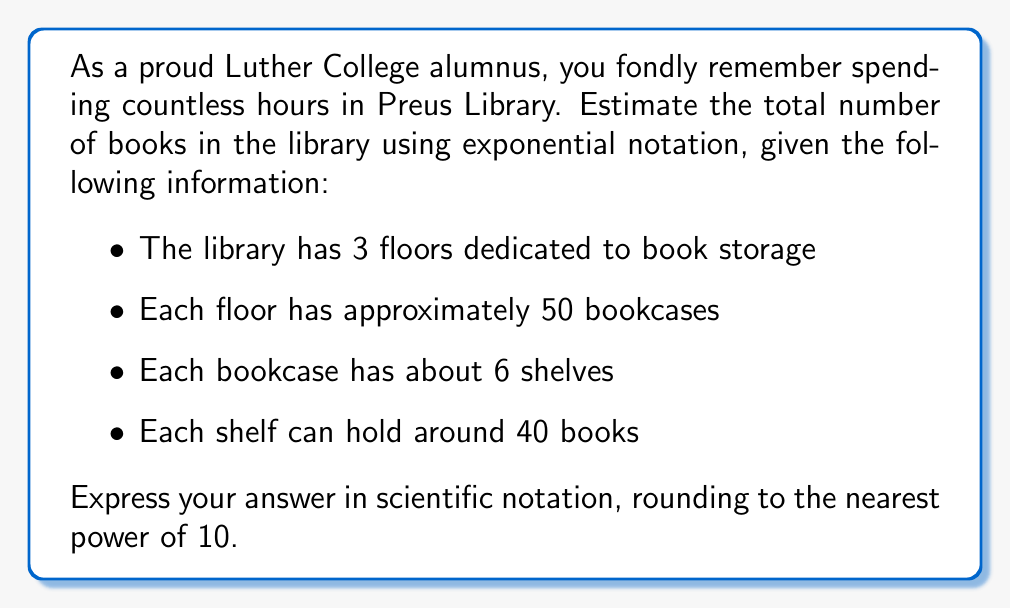Can you answer this question? Let's approach this step-by-step:

1) First, let's calculate the total number of books:
   
   $$ \text{Total books} = \text{floors} \times \text{bookcases per floor} \times \text{shelves per bookcase} \times \text{books per shelf} $$
   
   $$ \text{Total books} = 3 \times 50 \times 6 \times 40 $$

2) Let's multiply these numbers:
   
   $$ \text{Total books} = 36,000 $$

3) To express this in scientific notation, we need to write it in the form $a \times 10^n$ where $1 \leq a < 10$:
   
   $$ 36,000 = 3.6 \times 10^4 $$

4) Since we're asked to round to the nearest power of 10, we need to decide between $10^4$ and $10^5$. 
   
   $3.6 \times 10^4$ is closer to $1 \times 10^4$ than to $1 \times 10^5$, so we round down.

Therefore, our estimate rounded to the nearest power of 10 is $10^4$ or 10,000 books.
Answer: $10^4$ books 